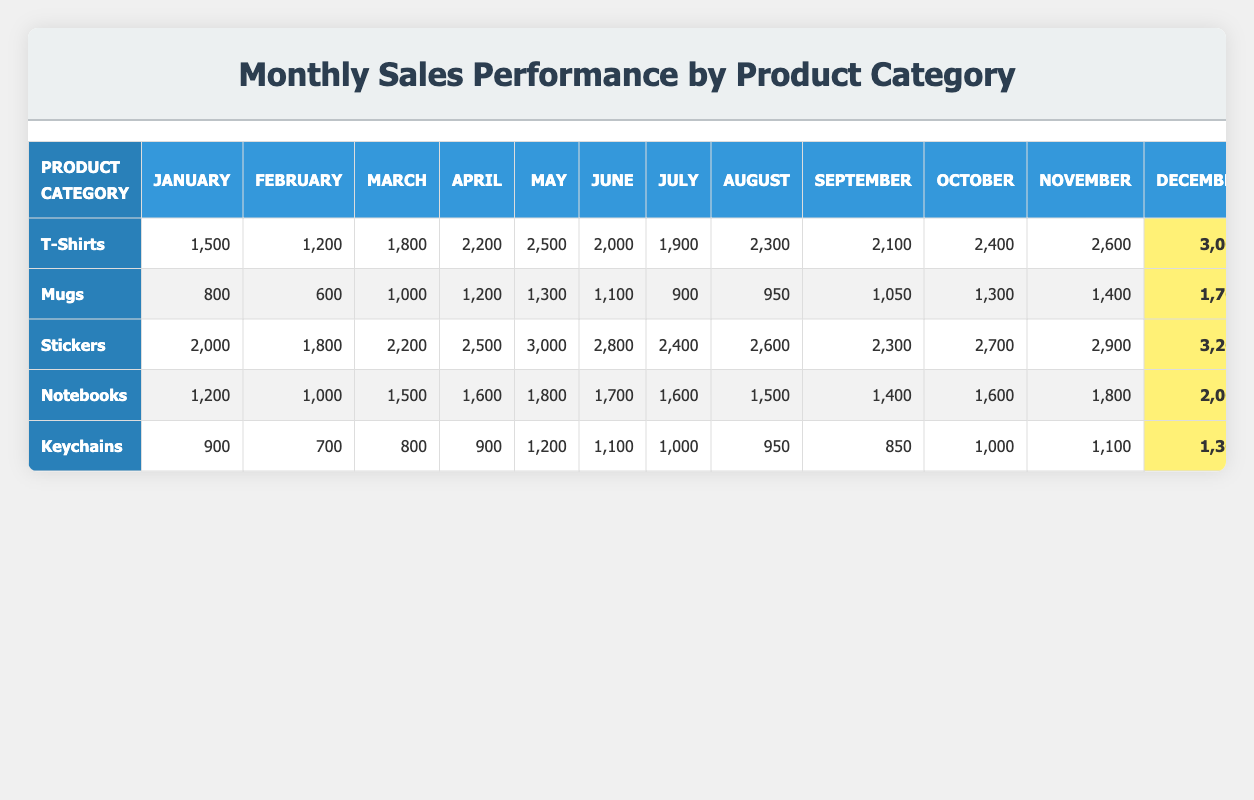What is the total sales for T-Shirts in the year? To find the total sales for T-Shirts, I will sum all the values from January to December: 1500 + 1200 + 1800 + 2200 + 2500 + 2000 + 1900 + 2300 + 2100 + 2400 + 2600 + 3000 = 25,600
Answer: 25600 Which month had the highest sales for Mugs? Looking at the sales data for Mugs, December shows the highest sales at 1700. The other months had lower values ranging from 600 to 1400.
Answer: December What was the average monthly sales for Stickers? The total sales for Stickers from January to December is 2000 + 1800 + 2200 + 2500 + 3000 + 2800 + 2400 + 2600 + 2300 + 2700 + 2900 + 3200 = 31700. There are 12 months, so I divide 31700 by 12 to get an average of approximately 2641.67.
Answer: 2641.67 Did Notebooks surpass 2000 sales in any month? By checking the sales figures for Notebooks, I can see that the maximum value reached is 2000 in December. This indicates that they did not surpass 2000 in any month since the December value is the exact match.
Answer: No What is the difference in sales between the best-selling month for T-Shirts and Keychains? The best-selling month for T-Shirts is December with sales of 3000, and for Keychains it is December too, with sales of 1300. The difference is calculated by subtracting the Keychain sales from T-Shirt sales: 3000 - 1300 = 1700.
Answer: 1700 Which product category had the highest sales in May? Looking at the sales data for May, T-Shirts had the highest sales with 2500, compared to other categories like Stickers at 3000, Mugs at 1300, Notebooks at 1800, and Keychains at 1200.
Answer: Stickers Was there any month when Keychains had less than 900 in sales? Checking the sales data for Keychains, the lowest value occurs in February where sales were 700. This confirms that there was indeed a month with sales below 900.
Answer: Yes What are the total sales for all product categories in July? To get the total sales for July, I will sum the sales from each category for that month: T-Shirts 1900 + Mugs 900 + Stickers 2400 + Notebooks 1600 + Keychains 1000 = 6000.
Answer: 6000 What was the sales trend for T-Shirts over the months? T-Shirts sales started at 1500 in January and showed an increasing trend each month, peaking at 3000 in December. This indicates strong growth in sales over the year.
Answer: Increasing trend 